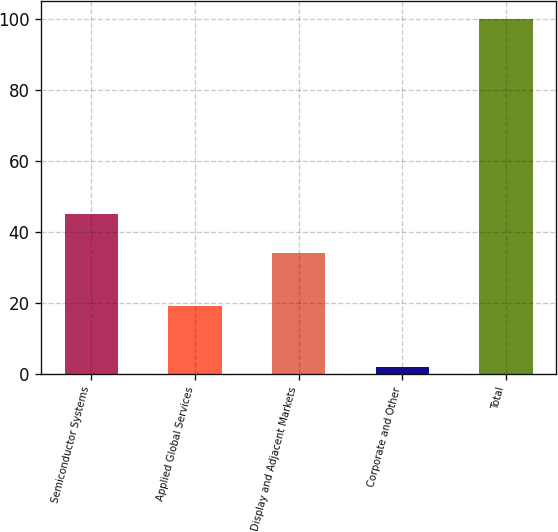Convert chart. <chart><loc_0><loc_0><loc_500><loc_500><bar_chart><fcel>Semiconductor Systems<fcel>Applied Global Services<fcel>Display and Adjacent Markets<fcel>Corporate and Other<fcel>Total<nl><fcel>45<fcel>19<fcel>34<fcel>2<fcel>100<nl></chart> 